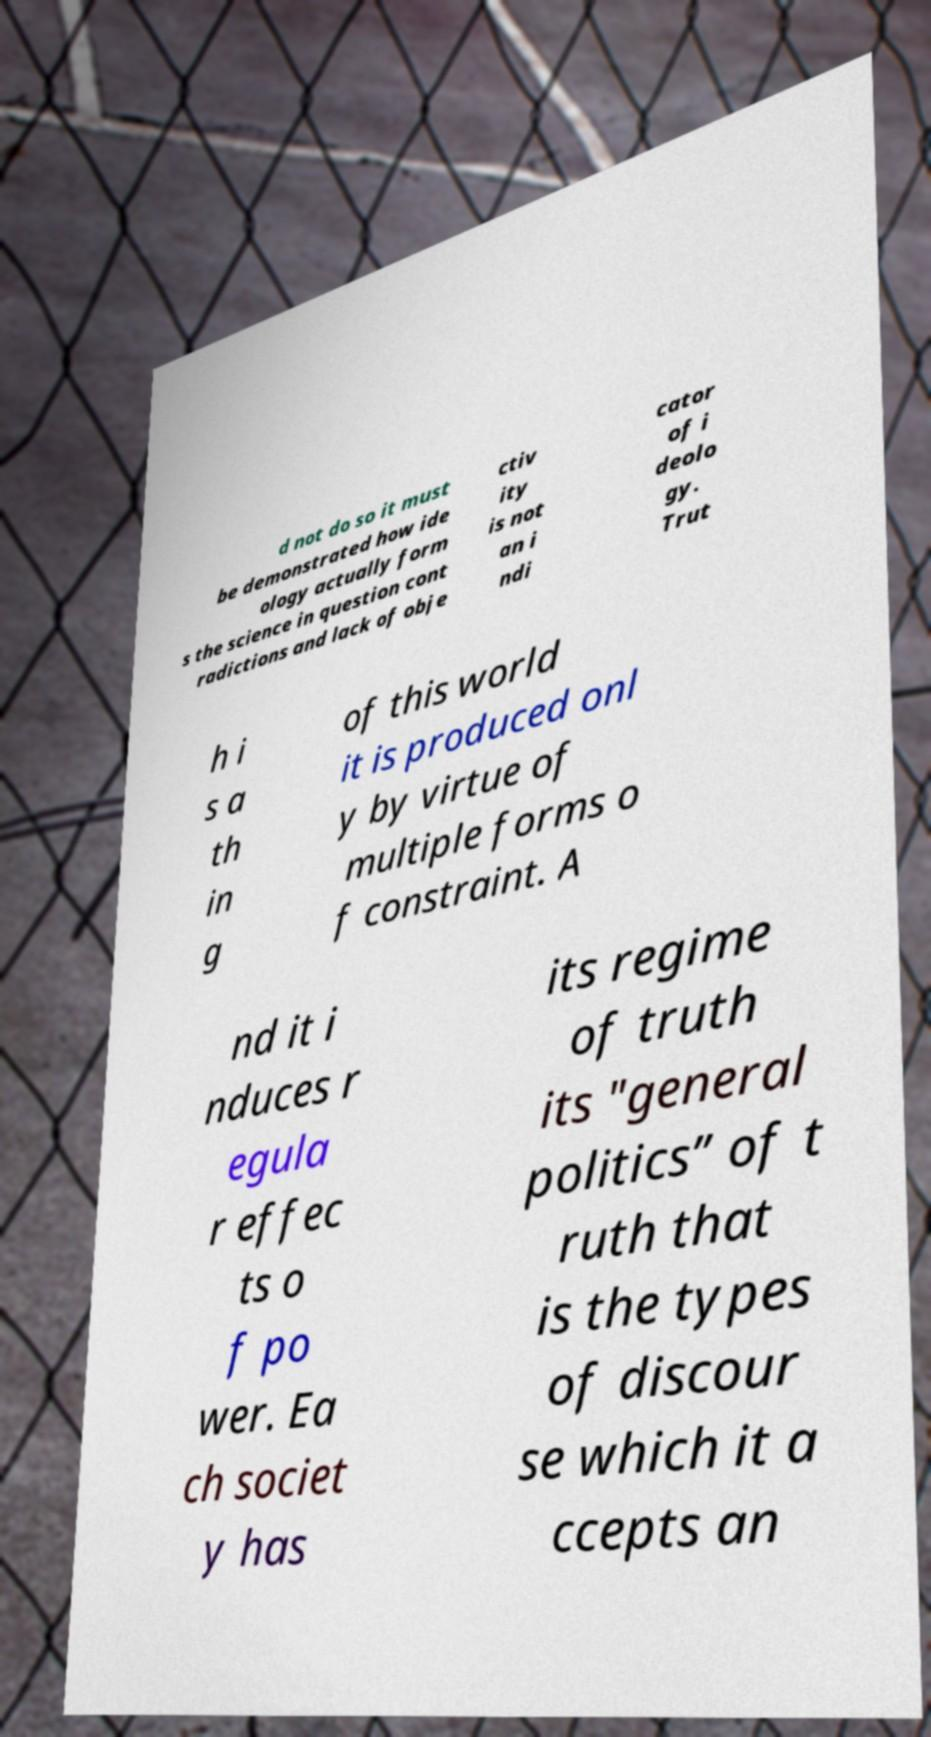For documentation purposes, I need the text within this image transcribed. Could you provide that? d not do so it must be demonstrated how ide ology actually form s the science in question cont radictions and lack of obje ctiv ity is not an i ndi cator of i deolo gy. Trut h i s a th in g of this world it is produced onl y by virtue of multiple forms o f constraint. A nd it i nduces r egula r effec ts o f po wer. Ea ch societ y has its regime of truth its "general politics” of t ruth that is the types of discour se which it a ccepts an 